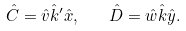<formula> <loc_0><loc_0><loc_500><loc_500>\hat { C } = \hat { v } \hat { k } ^ { \prime } \hat { x } , \quad \hat { D } = \hat { w } \hat { k } \hat { y } .</formula> 